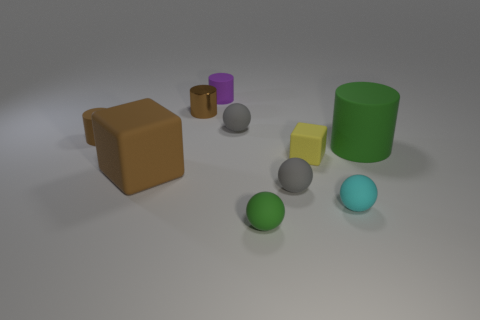Subtract 1 cylinders. How many cylinders are left? 3 Subtract all cylinders. How many objects are left? 6 Subtract 0 blue cubes. How many objects are left? 10 Subtract all big matte objects. Subtract all big spheres. How many objects are left? 8 Add 5 tiny balls. How many tiny balls are left? 9 Add 9 gray rubber cubes. How many gray rubber cubes exist? 9 